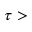Convert formula to latex. <formula><loc_0><loc_0><loc_500><loc_500>\tau ></formula> 